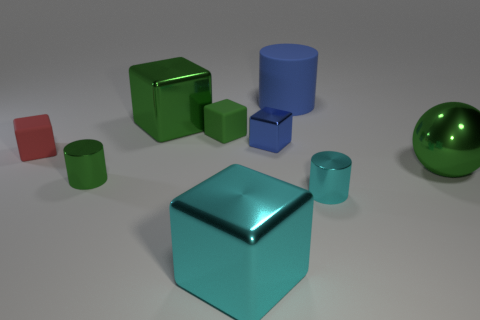What is the shape of the large metallic thing on the right side of the tiny cylinder that is right of the cube that is in front of the tiny red matte cube? The large metallic object situated to the right of the tiny cylinder, which in turn is to the right of the cube located in front of the tiny red matte cube, is a sphere. Its smooth, shiny surface reflects light differently than the other objects around it, indicating its metallic material. 